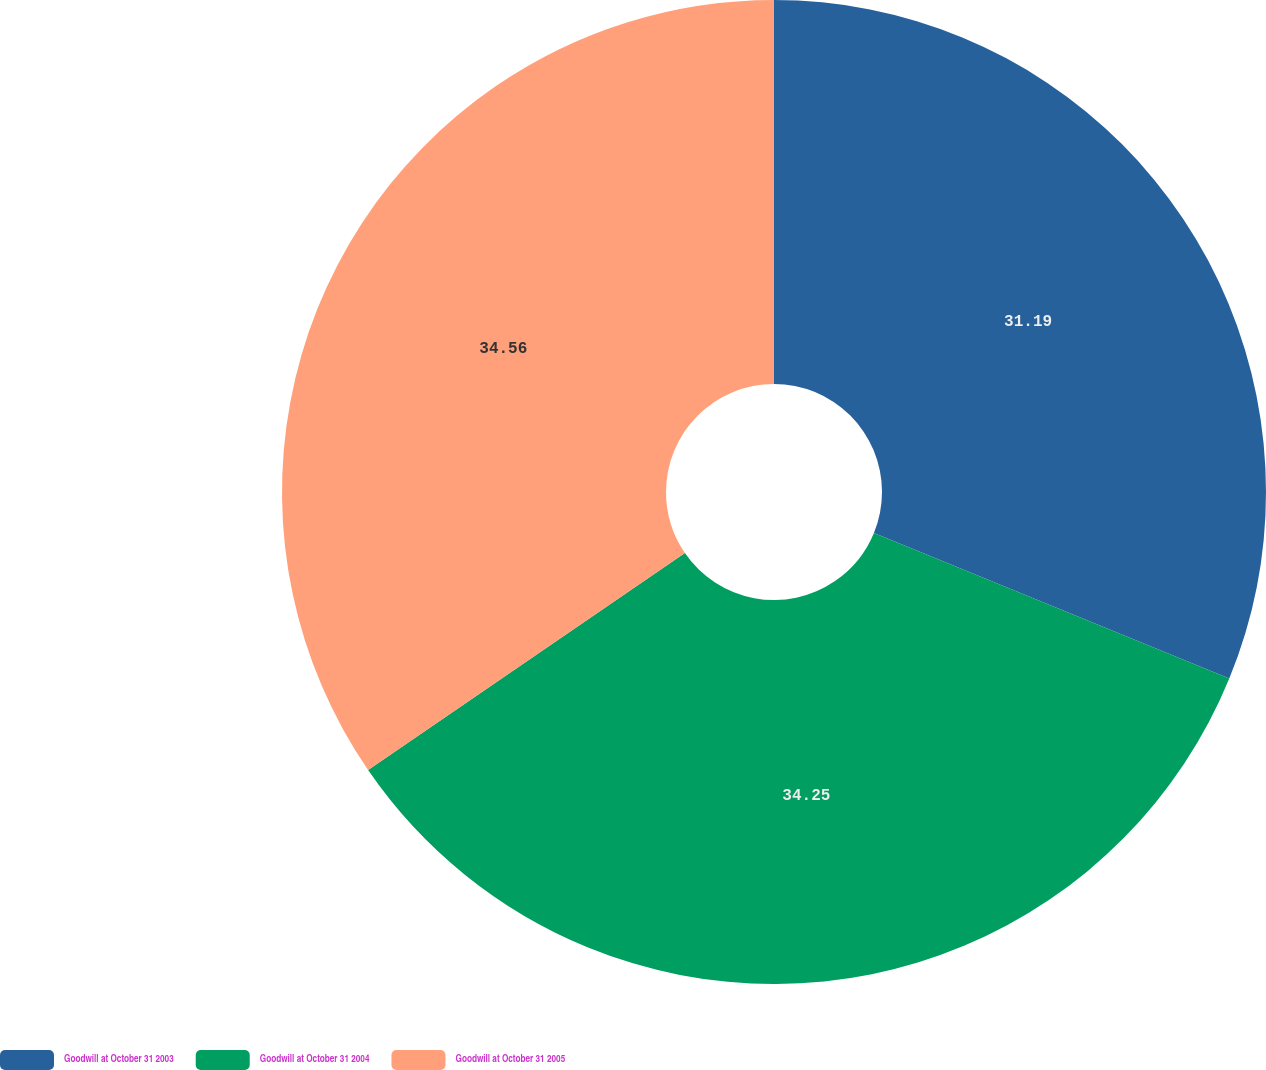Convert chart to OTSL. <chart><loc_0><loc_0><loc_500><loc_500><pie_chart><fcel>Goodwill at October 31 2003<fcel>Goodwill at October 31 2004<fcel>Goodwill at October 31 2005<nl><fcel>31.19%<fcel>34.25%<fcel>34.56%<nl></chart> 